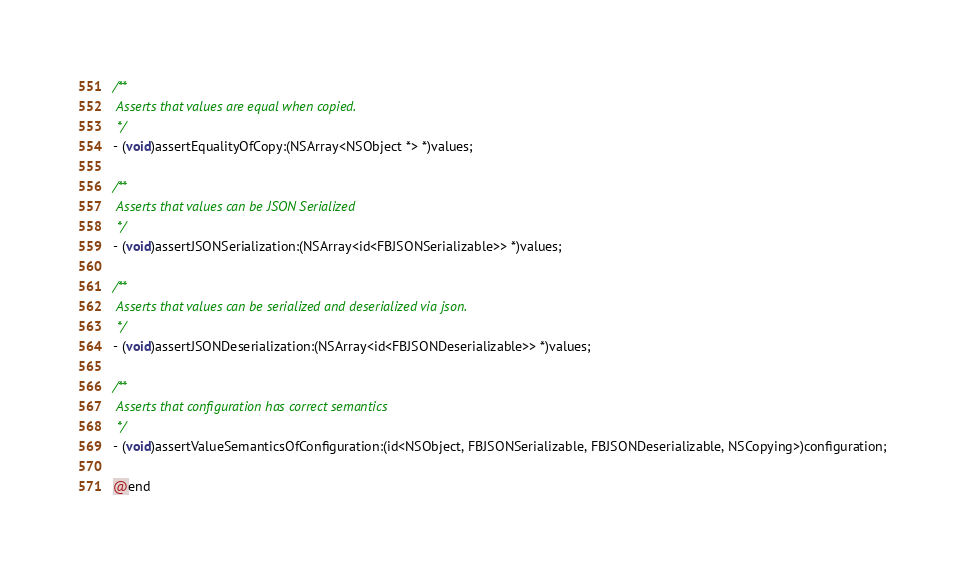<code> <loc_0><loc_0><loc_500><loc_500><_C_>/**
 Asserts that values are equal when copied.
 */
- (void)assertEqualityOfCopy:(NSArray<NSObject *> *)values;

/**
 Asserts that values can be JSON Serialized
 */
- (void)assertJSONSerialization:(NSArray<id<FBJSONSerializable>> *)values;

/**
 Asserts that values can be serialized and deserialized via json.
 */
- (void)assertJSONDeserialization:(NSArray<id<FBJSONDeserializable>> *)values;

/**
 Asserts that configuration has correct semantics
 */
- (void)assertValueSemanticsOfConfiguration:(id<NSObject, FBJSONSerializable, FBJSONDeserializable, NSCopying>)configuration;

@end
</code> 